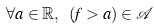<formula> <loc_0><loc_0><loc_500><loc_500>\forall a \in \mathbb { R } , \text { } ( f > a ) \in \mathcal { A }</formula> 